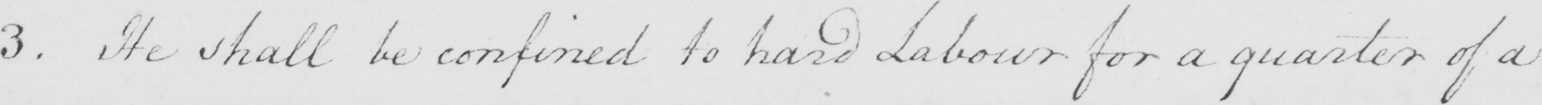Please transcribe the handwritten text in this image. 3 . He shall be confined to hard Labour for a quarter of a 